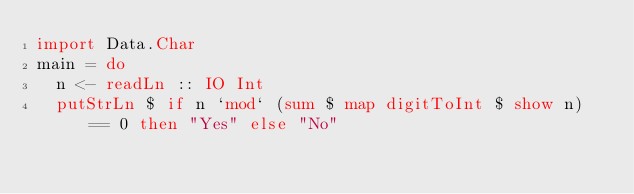<code> <loc_0><loc_0><loc_500><loc_500><_Haskell_>import Data.Char
main = do
  n <- readLn :: IO Int
  putStrLn $ if n `mod` (sum $ map digitToInt $ show n) == 0 then "Yes" else "No"</code> 